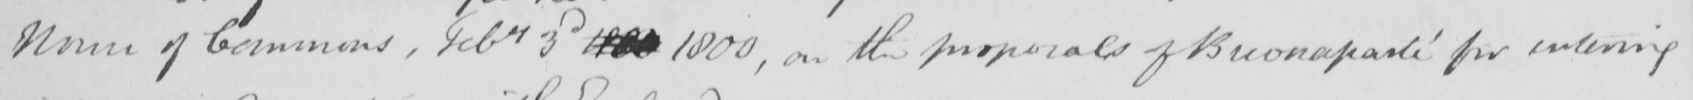What text is written in this handwritten line? House of Commons , Febry 3d 1801 1800 , on the proposals of Buonaparte for entering 